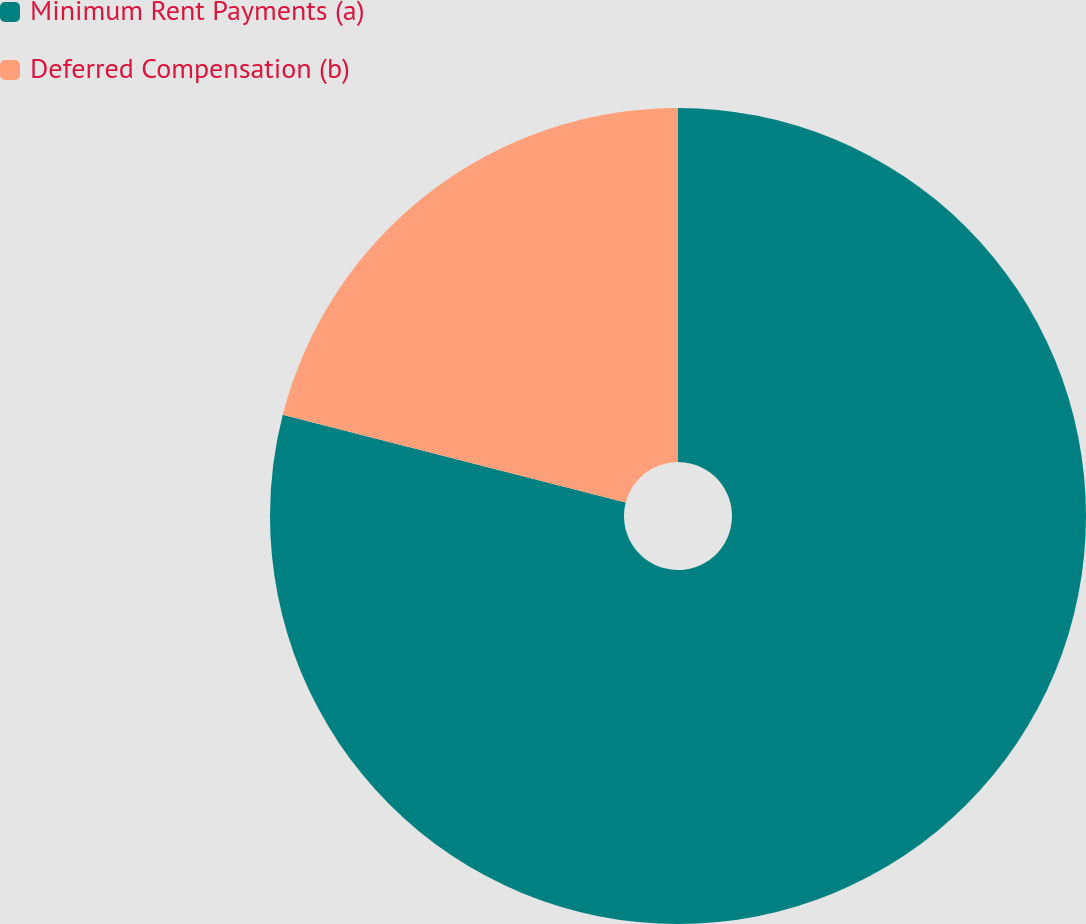Convert chart. <chart><loc_0><loc_0><loc_500><loc_500><pie_chart><fcel>Minimum Rent Payments (a)<fcel>Deferred Compensation (b)<nl><fcel>78.99%<fcel>21.01%<nl></chart> 